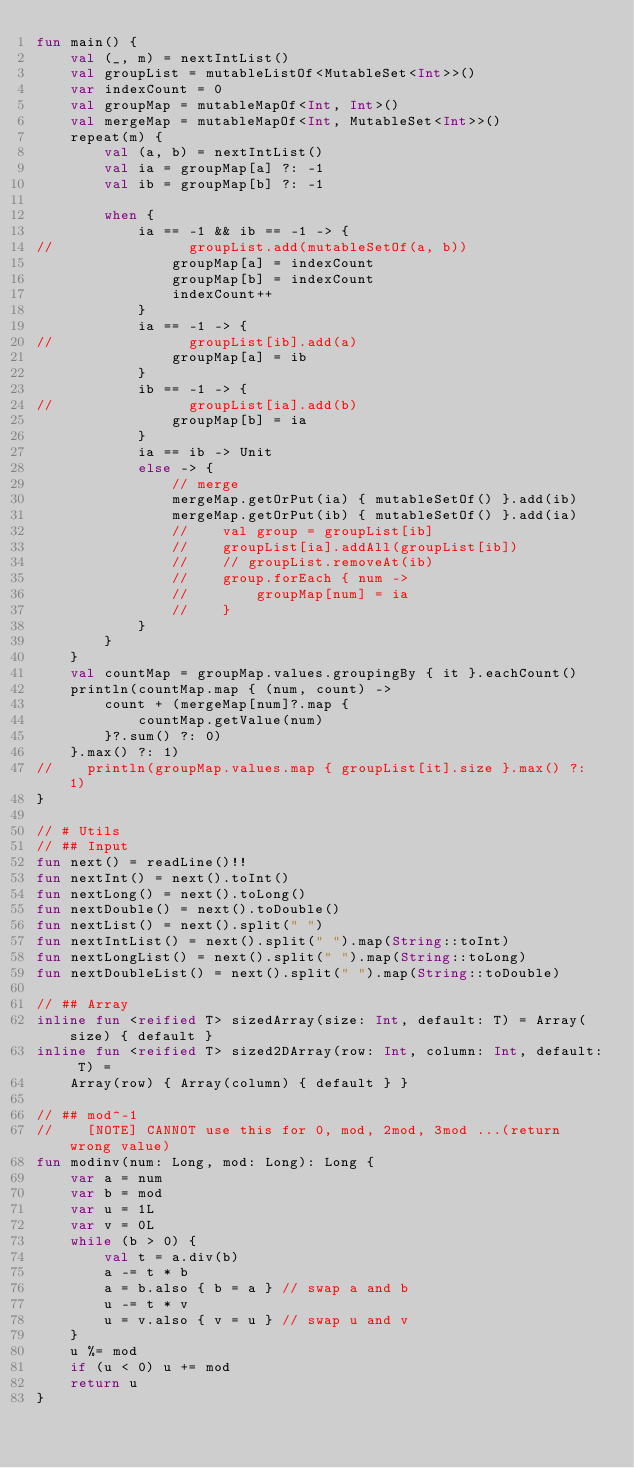Convert code to text. <code><loc_0><loc_0><loc_500><loc_500><_Kotlin_>fun main() {
    val (_, m) = nextIntList()
    val groupList = mutableListOf<MutableSet<Int>>()
    var indexCount = 0
    val groupMap = mutableMapOf<Int, Int>()
    val mergeMap = mutableMapOf<Int, MutableSet<Int>>()
    repeat(m) {
        val (a, b) = nextIntList()
        val ia = groupMap[a] ?: -1
        val ib = groupMap[b] ?: -1

        when {
            ia == -1 && ib == -1 -> {
//                groupList.add(mutableSetOf(a, b))
                groupMap[a] = indexCount
                groupMap[b] = indexCount
                indexCount++
            }
            ia == -1 -> {
//                groupList[ib].add(a)
                groupMap[a] = ib
            }
            ib == -1 -> {
//                groupList[ia].add(b)
                groupMap[b] = ia
            }
            ia == ib -> Unit
            else -> {
                // merge
                mergeMap.getOrPut(ia) { mutableSetOf() }.add(ib)
                mergeMap.getOrPut(ib) { mutableSetOf() }.add(ia)
                //    val group = groupList[ib]
                //    groupList[ia].addAll(groupList[ib])
                //    // groupList.removeAt(ib)
                //    group.forEach { num ->
                //        groupMap[num] = ia
                //    }
            }
        }
    }
    val countMap = groupMap.values.groupingBy { it }.eachCount()
    println(countMap.map { (num, count) ->
        count + (mergeMap[num]?.map {
            countMap.getValue(num)
        }?.sum() ?: 0)
    }.max() ?: 1)
//    println(groupMap.values.map { groupList[it].size }.max() ?: 1)
}

// # Utils
// ## Input
fun next() = readLine()!!
fun nextInt() = next().toInt()
fun nextLong() = next().toLong()
fun nextDouble() = next().toDouble()
fun nextList() = next().split(" ")
fun nextIntList() = next().split(" ").map(String::toInt)
fun nextLongList() = next().split(" ").map(String::toLong)
fun nextDoubleList() = next().split(" ").map(String::toDouble)

// ## Array
inline fun <reified T> sizedArray(size: Int, default: T) = Array(size) { default }
inline fun <reified T> sized2DArray(row: Int, column: Int, default: T) =
    Array(row) { Array(column) { default } }

// ## mod^-1
//    [NOTE] CANNOT use this for 0, mod, 2mod, 3mod ...(return wrong value)
fun modinv(num: Long, mod: Long): Long {
    var a = num
    var b = mod
    var u = 1L
    var v = 0L
    while (b > 0) {
        val t = a.div(b)
        a -= t * b
        a = b.also { b = a } // swap a and b
        u -= t * v
        u = v.also { v = u } // swap u and v
    }
    u %= mod
    if (u < 0) u += mod
    return u
}</code> 